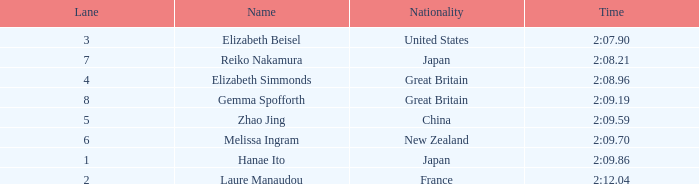What is the highest ranking achieved by laure manaudou? 8.0. 